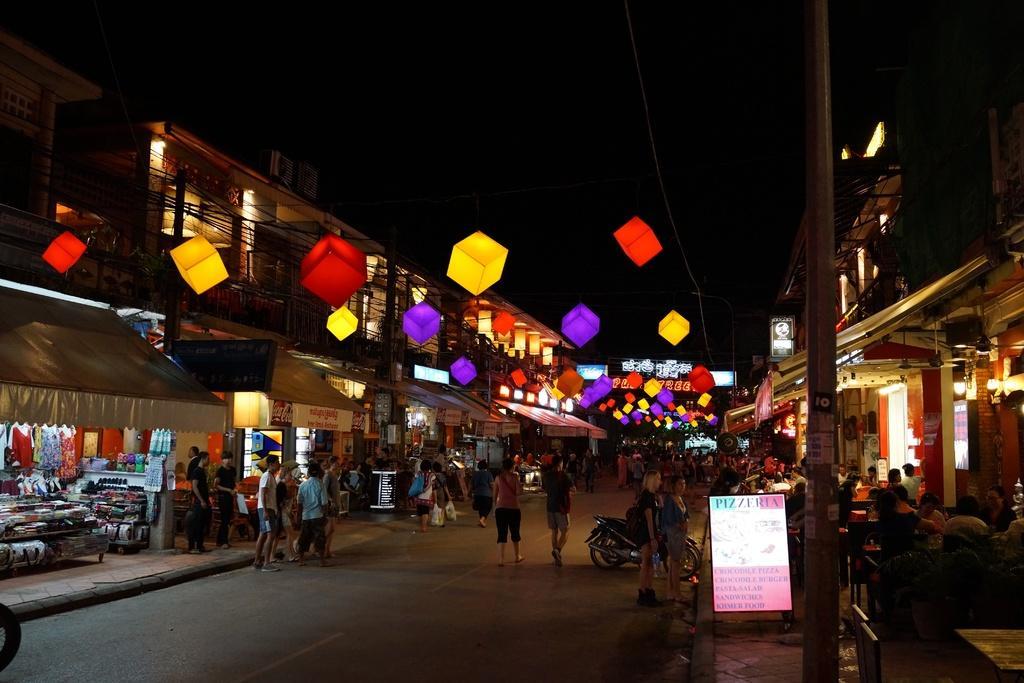Could you give a brief overview of what you see in this image? This image consists of many people walking and standing on the road. At the top, there are cubes in which there are lights. To the left and right, there are stalls and shop. In the middle, we can see the bikes parked on the road. At the top, there is a sky. 